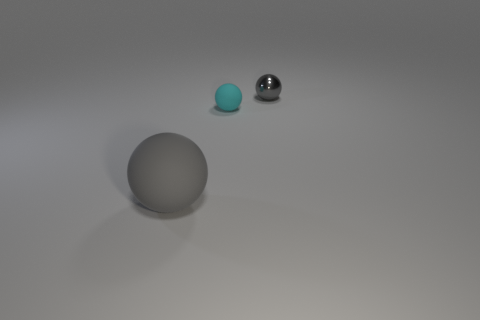Add 1 gray rubber things. How many objects exist? 4 Add 1 large rubber things. How many large rubber things are left? 2 Add 2 red rubber things. How many red rubber things exist? 2 Subtract 0 blue cubes. How many objects are left? 3 Subtract all big balls. Subtract all tiny matte objects. How many objects are left? 1 